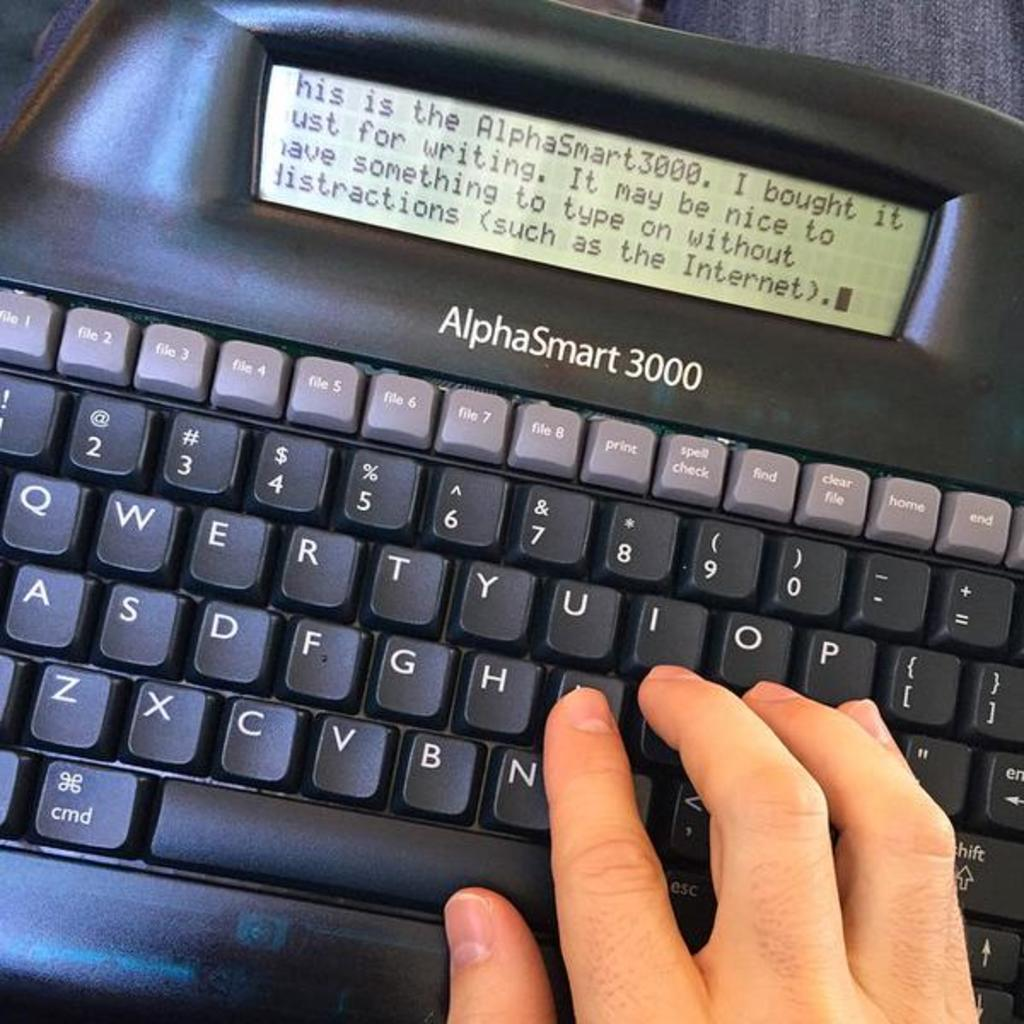<image>
Render a clear and concise summary of the photo. An alphaSmart 3000 keyboard with a small display screen. 